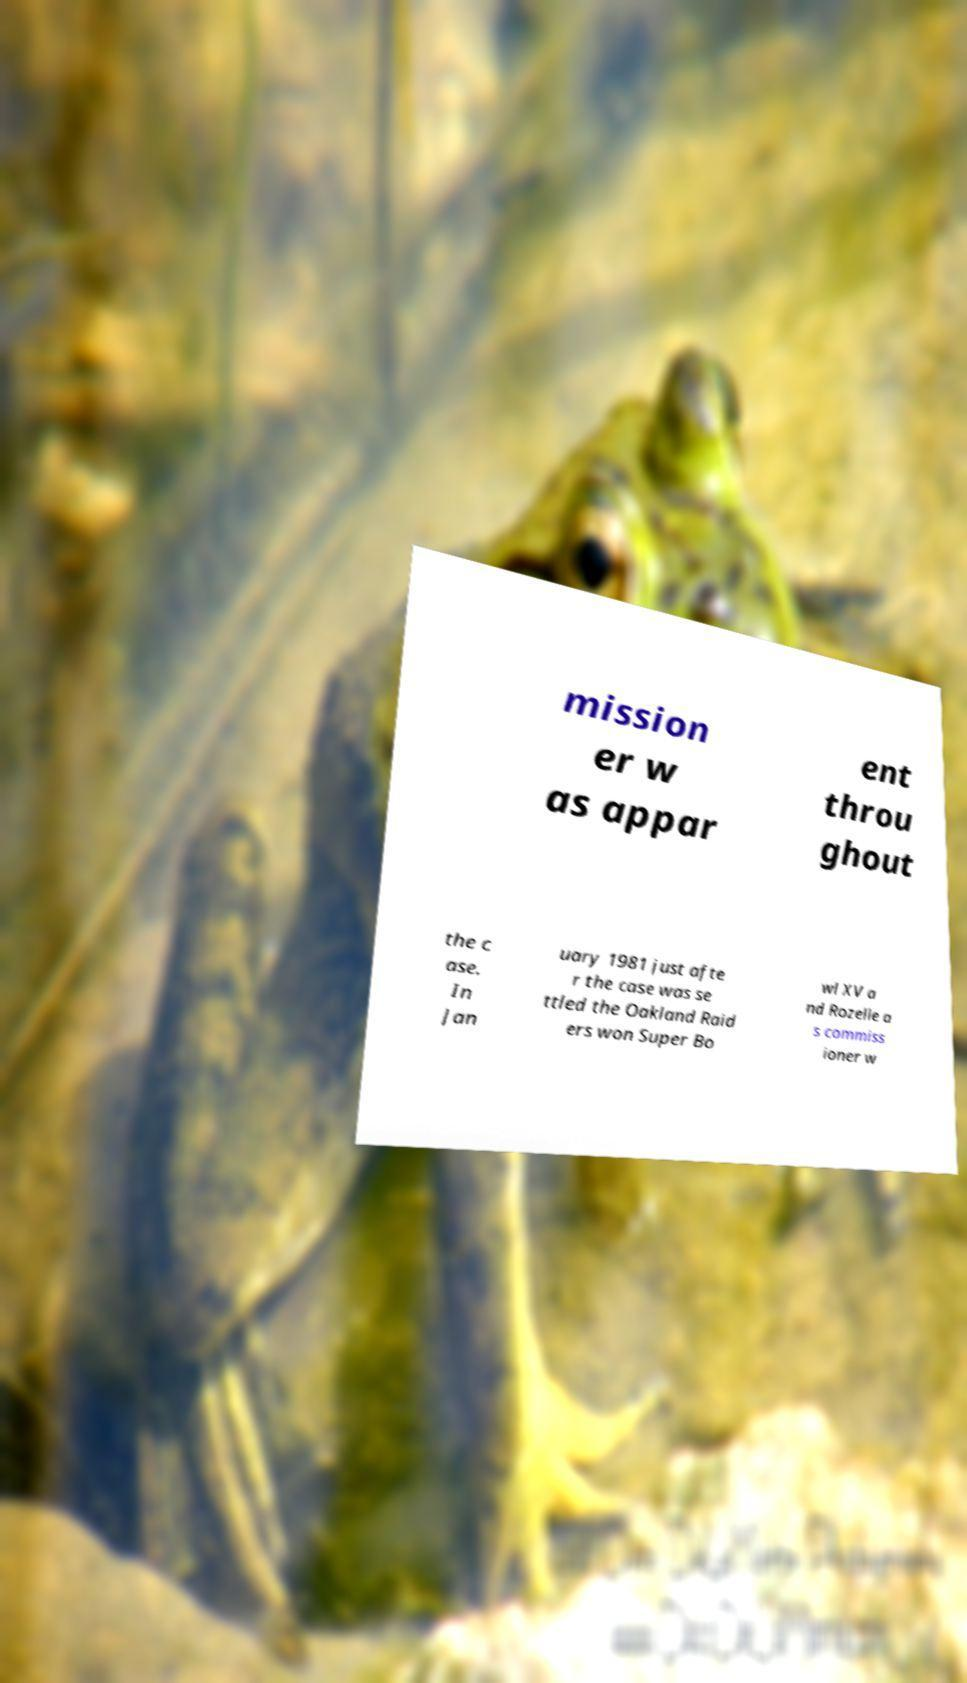What messages or text are displayed in this image? I need them in a readable, typed format. mission er w as appar ent throu ghout the c ase. In Jan uary 1981 just afte r the case was se ttled the Oakland Raid ers won Super Bo wl XV a nd Rozelle a s commiss ioner w 